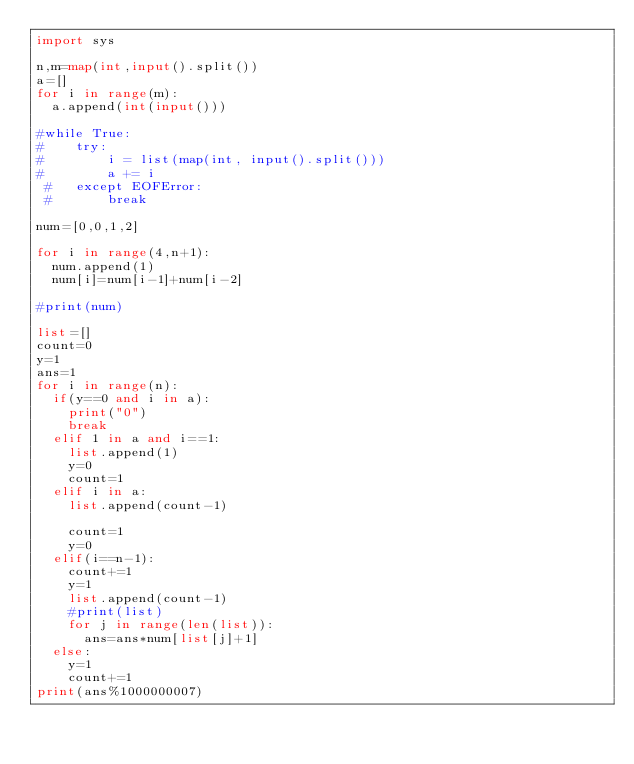Convert code to text. <code><loc_0><loc_0><loc_500><loc_500><_Python_>import sys

n,m=map(int,input().split())
a=[]
for i in range(m):
	a.append(int(input()))

#while True:
#    try:
#        i = list(map(int, input().split()))
#        a += i
 #   except EOFError:
 #       break

num=[0,0,1,2]

for i in range(4,n+1):
	num.append(1)
	num[i]=num[i-1]+num[i-2]

#print(num)

list=[]
count=0
y=1
ans=1
for i in range(n):
	if(y==0 and i in a):
		print("0")
		break
	elif 1 in a and i==1:
		list.append(1)
		y=0
		count=1
	elif i in a:
		list.append(count-1)

		count=1
		y=0
	elif(i==n-1):
		count+=1
		y=1
		list.append(count-1)
		#print(list)
		for j in range(len(list)):
			ans=ans*num[list[j]+1]
	else:
		y=1
		count+=1
print(ans%1000000007)
</code> 